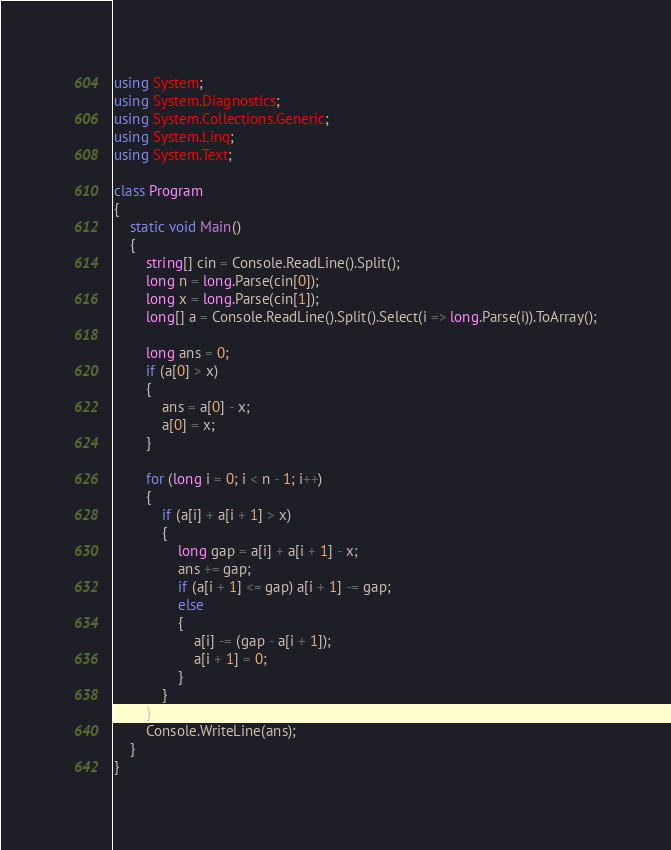Convert code to text. <code><loc_0><loc_0><loc_500><loc_500><_C#_>using System;
using System.Diagnostics;
using System.Collections.Generic;
using System.Linq;
using System.Text;

class Program
{
    static void Main()
    {
        string[] cin = Console.ReadLine().Split();
        long n = long.Parse(cin[0]);
        long x = long.Parse(cin[1]);
        long[] a = Console.ReadLine().Split().Select(i => long.Parse(i)).ToArray();

        long ans = 0;
        if (a[0] > x)
        {
            ans = a[0] - x;
            a[0] = x;
        }

        for (long i = 0; i < n - 1; i++)
        {
            if (a[i] + a[i + 1] > x)
            {
                long gap = a[i] + a[i + 1] - x;
                ans += gap;
                if (a[i + 1] <= gap) a[i + 1] -= gap;
                else
                {
                    a[i] -= (gap - a[i + 1]);
                    a[i + 1] = 0;
                }
            }
        }
        Console.WriteLine(ans);
    }
}</code> 